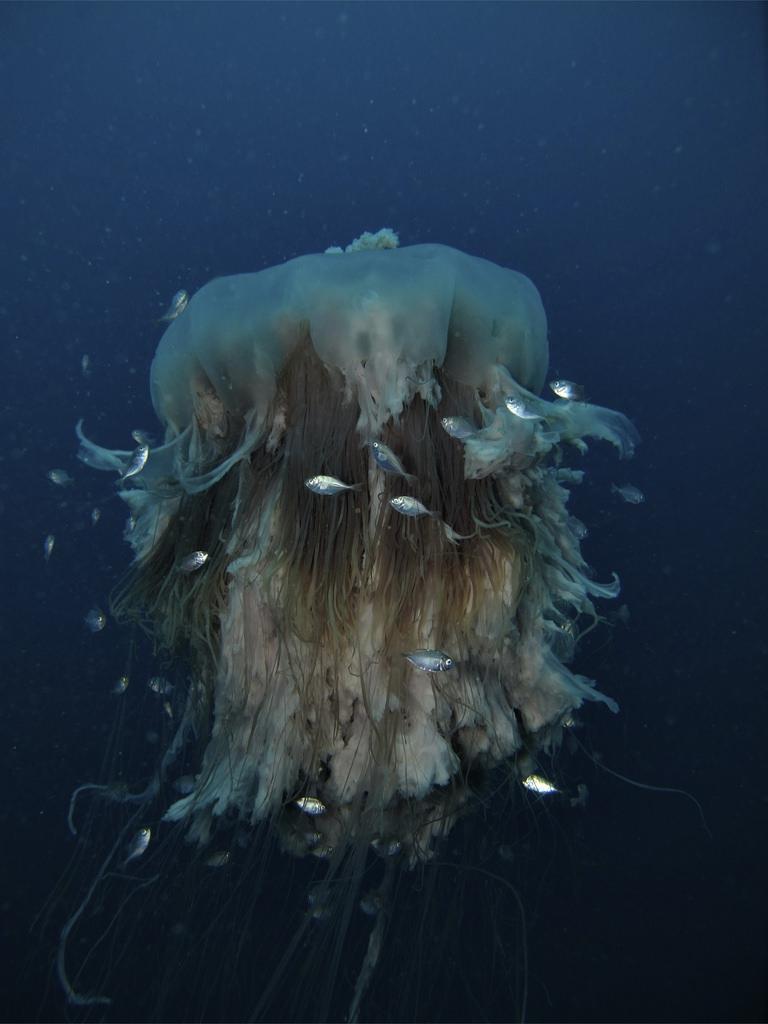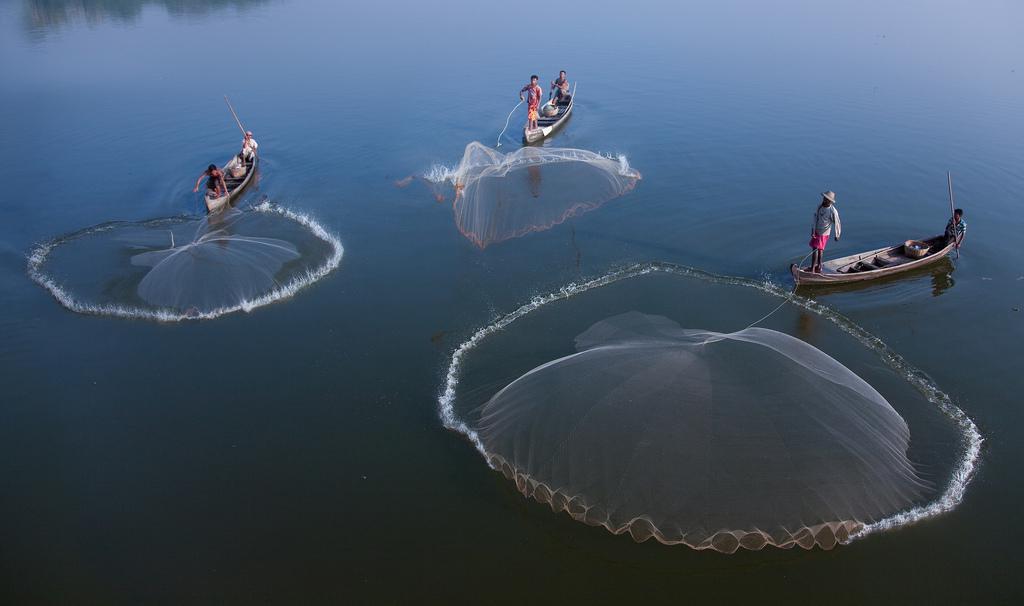The first image is the image on the left, the second image is the image on the right. Given the left and right images, does the statement "There is at least one human visible." hold true? Answer yes or no. Yes. The first image is the image on the left, the second image is the image on the right. Analyze the images presented: Is the assertion "One jellyfish has pink hues." valid? Answer yes or no. No. 